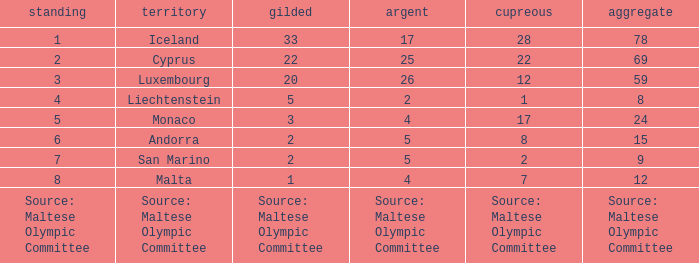How many bronze medals does the nation ranked number 1 have? 28.0. 